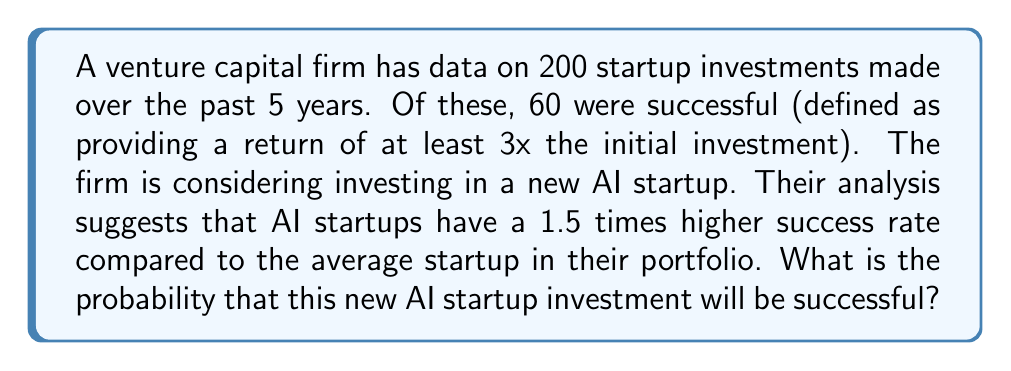Show me your answer to this math problem. Let's approach this step-by-step:

1) First, we need to calculate the overall success rate of startups in the firm's portfolio:

   $$P(\text{Success}) = \frac{\text{Number of successful startups}}{\text{Total number of startups}}$$
   
   $$P(\text{Success}) = \frac{60}{200} = 0.3 \text{ or } 30\%$$

2) We're told that AI startups have a 1.5 times higher success rate. To calculate this:

   $$P(\text{Success for AI startup}) = 1.5 \times P(\text{Success})$$
   
   $$P(\text{Success for AI startup}) = 1.5 \times 0.3 = 0.45 \text{ or } 45\%$$

3) Therefore, the probability that this new AI startup investment will be successful is 0.45 or 45%.
Answer: 0.45 